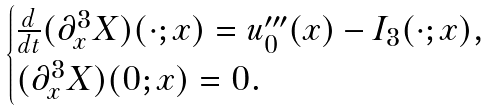<formula> <loc_0><loc_0><loc_500><loc_500>\begin{cases} \frac { d } { d t } ( \partial ^ { 3 } _ { x } X ) ( \cdot ; x ) = u ^ { \prime \prime \prime } _ { 0 } ( x ) - I _ { 3 } ( \cdot ; x ) , \\ ( \partial ^ { 3 } _ { x } X ) ( 0 ; x ) = 0 . \end{cases}</formula> 